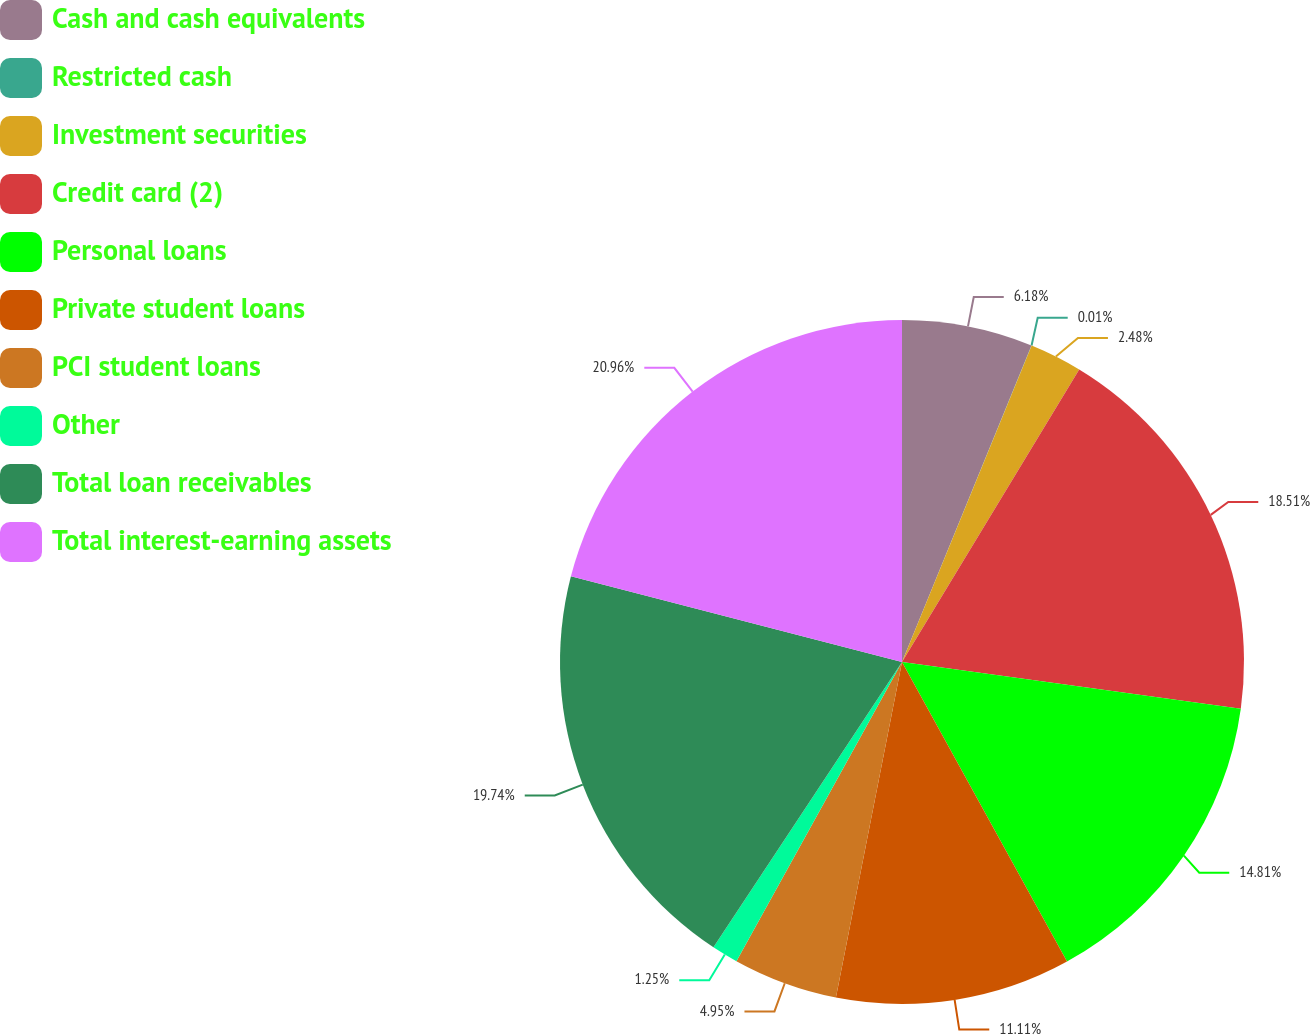Convert chart to OTSL. <chart><loc_0><loc_0><loc_500><loc_500><pie_chart><fcel>Cash and cash equivalents<fcel>Restricted cash<fcel>Investment securities<fcel>Credit card (2)<fcel>Personal loans<fcel>Private student loans<fcel>PCI student loans<fcel>Other<fcel>Total loan receivables<fcel>Total interest-earning assets<nl><fcel>6.18%<fcel>0.01%<fcel>2.48%<fcel>18.51%<fcel>14.81%<fcel>11.11%<fcel>4.95%<fcel>1.25%<fcel>19.74%<fcel>20.97%<nl></chart> 